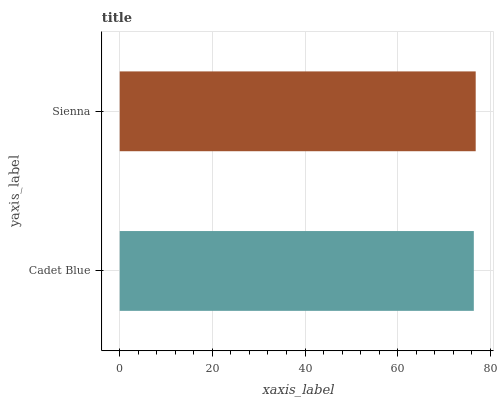Is Cadet Blue the minimum?
Answer yes or no. Yes. Is Sienna the maximum?
Answer yes or no. Yes. Is Sienna the minimum?
Answer yes or no. No. Is Sienna greater than Cadet Blue?
Answer yes or no. Yes. Is Cadet Blue less than Sienna?
Answer yes or no. Yes. Is Cadet Blue greater than Sienna?
Answer yes or no. No. Is Sienna less than Cadet Blue?
Answer yes or no. No. Is Sienna the high median?
Answer yes or no. Yes. Is Cadet Blue the low median?
Answer yes or no. Yes. Is Cadet Blue the high median?
Answer yes or no. No. Is Sienna the low median?
Answer yes or no. No. 